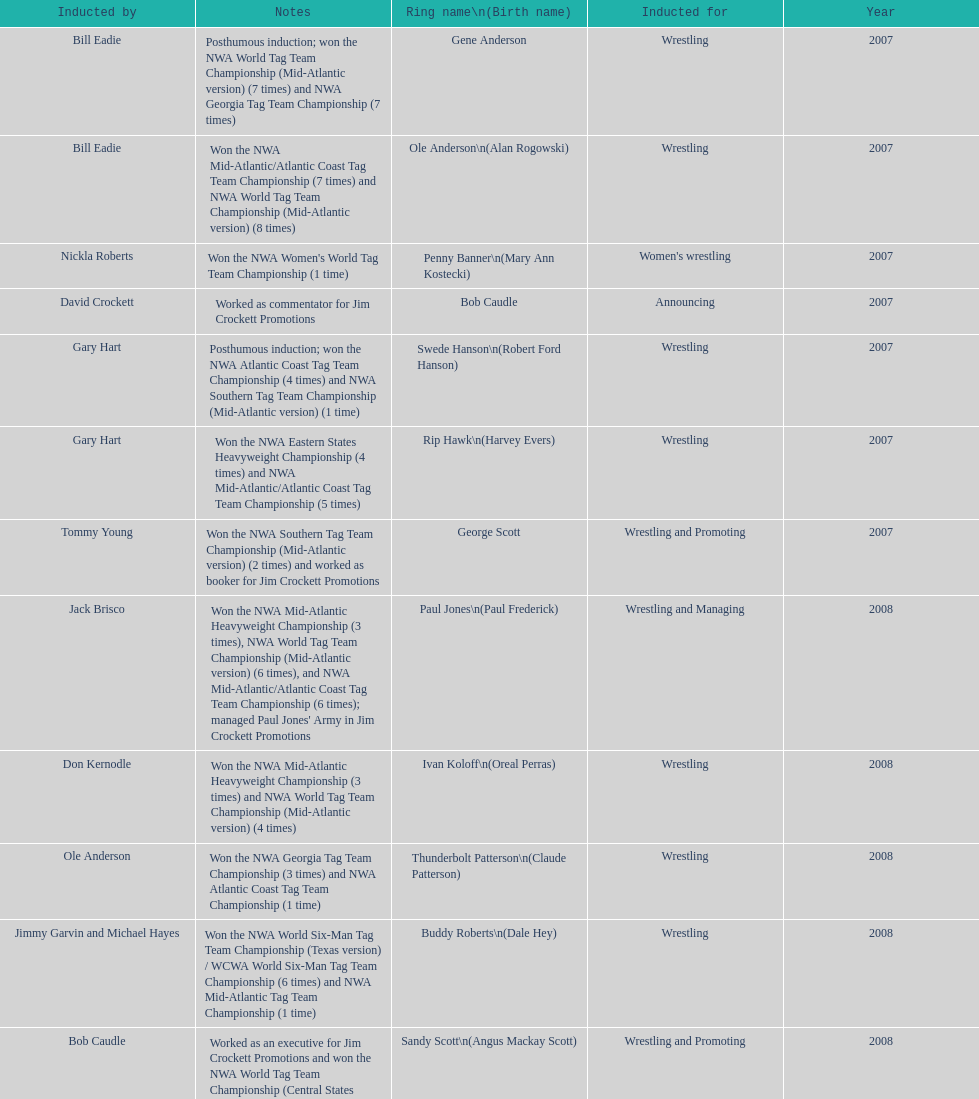How many members were inducted for announcing? 2. I'm looking to parse the entire table for insights. Could you assist me with that? {'header': ['Inducted by', 'Notes', 'Ring name\\n(Birth name)', 'Inducted for', 'Year'], 'rows': [['Bill Eadie', 'Posthumous induction; won the NWA World Tag Team Championship (Mid-Atlantic version) (7 times) and NWA Georgia Tag Team Championship (7 times)', 'Gene Anderson', 'Wrestling', '2007'], ['Bill Eadie', 'Won the NWA Mid-Atlantic/Atlantic Coast Tag Team Championship (7 times) and NWA World Tag Team Championship (Mid-Atlantic version) (8 times)', 'Ole Anderson\\n(Alan Rogowski)', 'Wrestling', '2007'], ['Nickla Roberts', "Won the NWA Women's World Tag Team Championship (1 time)", 'Penny Banner\\n(Mary Ann Kostecki)', "Women's wrestling", '2007'], ['David Crockett', 'Worked as commentator for Jim Crockett Promotions', 'Bob Caudle', 'Announcing', '2007'], ['Gary Hart', 'Posthumous induction; won the NWA Atlantic Coast Tag Team Championship (4 times) and NWA Southern Tag Team Championship (Mid-Atlantic version) (1 time)', 'Swede Hanson\\n(Robert Ford Hanson)', 'Wrestling', '2007'], ['Gary Hart', 'Won the NWA Eastern States Heavyweight Championship (4 times) and NWA Mid-Atlantic/Atlantic Coast Tag Team Championship (5 times)', 'Rip Hawk\\n(Harvey Evers)', 'Wrestling', '2007'], ['Tommy Young', 'Won the NWA Southern Tag Team Championship (Mid-Atlantic version) (2 times) and worked as booker for Jim Crockett Promotions', 'George Scott', 'Wrestling and Promoting', '2007'], ['Jack Brisco', "Won the NWA Mid-Atlantic Heavyweight Championship (3 times), NWA World Tag Team Championship (Mid-Atlantic version) (6 times), and NWA Mid-Atlantic/Atlantic Coast Tag Team Championship (6 times); managed Paul Jones' Army in Jim Crockett Promotions", 'Paul Jones\\n(Paul Frederick)', 'Wrestling and Managing', '2008'], ['Don Kernodle', 'Won the NWA Mid-Atlantic Heavyweight Championship (3 times) and NWA World Tag Team Championship (Mid-Atlantic version) (4 times)', 'Ivan Koloff\\n(Oreal Perras)', 'Wrestling', '2008'], ['Ole Anderson', 'Won the NWA Georgia Tag Team Championship (3 times) and NWA Atlantic Coast Tag Team Championship (1 time)', 'Thunderbolt Patterson\\n(Claude Patterson)', 'Wrestling', '2008'], ['Jimmy Garvin and Michael Hayes', 'Won the NWA World Six-Man Tag Team Championship (Texas version) / WCWA World Six-Man Tag Team Championship (6 times) and NWA Mid-Atlantic Tag Team Championship (1 time)', 'Buddy Roberts\\n(Dale Hey)', 'Wrestling', '2008'], ['Bob Caudle', 'Worked as an executive for Jim Crockett Promotions and won the NWA World Tag Team Championship (Central States version) (1 time) and NWA Southern Tag Team Championship (Mid-Atlantic version) (3 times)', 'Sandy Scott\\n(Angus Mackay Scott)', 'Wrestling and Promoting', '2008'], ['Magnum T.A.', 'Won the NWA United States Tag Team Championship (Tri-State version) (2 times) and NWA Texas Heavyweight Championship (1 time)', 'Grizzly Smith\\n(Aurelian Smith)', 'Wrestling', '2008'], ['Rip Hawk', 'Posthumous induction; won the NWA Atlantic Coast/Mid-Atlantic Tag Team Championship (8 times) and NWA Southern Tag Team Championship (Mid-Atlantic version) (6 times)', 'Johnny Weaver\\n(Kenneth Eugene Weaver)', 'Wrestling', '2008'], ['Jerry Jarrett & Steve Keirn', 'Won the NWA Southern Tag Team Championship (Mid-America version) (2 times) and NWA World Tag Team Championship (Mid-America version) (6 times)', 'Don Fargo\\n(Don Kalt)', 'Wrestling', '2009'], ['Jerry Jarrett & Steve Keirn', 'Won the NWA World Tag Team Championship (Mid-America version) (10 times) and NWA Southern Tag Team Championship (Mid-America version) (22 times)', 'Jackie Fargo\\n(Henry Faggart)', 'Wrestling', '2009'], ['Jerry Jarrett & Steve Keirn', 'Posthumous induction; won the NWA Southern Tag Team Championship (Mid-America version) (3 times)', 'Sonny Fargo\\n(Jack Lewis Faggart)', 'Wrestling', '2009'], ['Sir Oliver Humperdink', 'Posthumous induction; worked as a booker in World Class Championship Wrestling and managed several wrestlers in Mid-Atlantic Championship Wrestling', 'Gary Hart\\n(Gary Williams)', 'Managing and Promoting', '2009'], ['Tully Blanchard', 'Posthumous induction; won the NWA Mid-Atlantic Heavyweight Championship (6 times) and NWA World Tag Team Championship (Mid-Atlantic version) (4 times)', 'Wahoo McDaniel\\n(Edward McDaniel)', 'Wrestling', '2009'], ['Ric Flair', 'Won the NWA Texas Heavyweight Championship (1 time) and NWA World Tag Team Championship (Mid-Atlantic version) (1 time)', 'Blackjack Mulligan\\n(Robert Windham)', 'Wrestling', '2009'], ['Brad Anderson, Tommy Angel & David Isley', 'Won the NWA Atlantic Coast Tag Team Championship (2 times)', 'Nelson Royal', 'Wrestling', '2009'], ['Dave Brown', 'Worked as commentator for wrestling events in the Memphis area', 'Lance Russell', 'Announcing', '2009']]} 